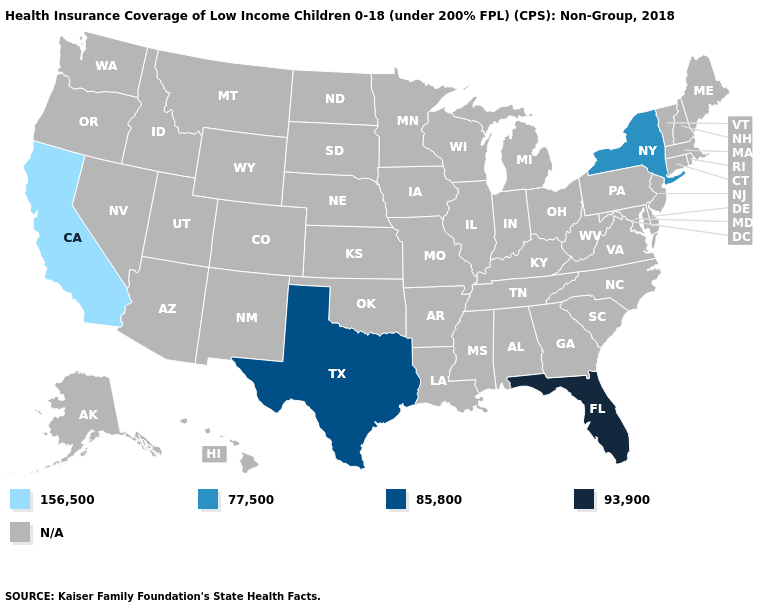What is the value of Virginia?
Quick response, please. N/A. What is the value of Missouri?
Answer briefly. N/A. Which states have the highest value in the USA?
Concise answer only. Florida. Name the states that have a value in the range 156,500?
Answer briefly. California. What is the lowest value in states that border New Mexico?
Concise answer only. 85,800. What is the lowest value in the Northeast?
Write a very short answer. 77,500. Which states have the lowest value in the USA?
Short answer required. California. Name the states that have a value in the range 93,900?
Short answer required. Florida. How many symbols are there in the legend?
Write a very short answer. 5. Name the states that have a value in the range N/A?
Be succinct. Alabama, Alaska, Arizona, Arkansas, Colorado, Connecticut, Delaware, Georgia, Hawaii, Idaho, Illinois, Indiana, Iowa, Kansas, Kentucky, Louisiana, Maine, Maryland, Massachusetts, Michigan, Minnesota, Mississippi, Missouri, Montana, Nebraska, Nevada, New Hampshire, New Jersey, New Mexico, North Carolina, North Dakota, Ohio, Oklahoma, Oregon, Pennsylvania, Rhode Island, South Carolina, South Dakota, Tennessee, Utah, Vermont, Virginia, Washington, West Virginia, Wisconsin, Wyoming. Does Texas have the highest value in the USA?
Quick response, please. No. 